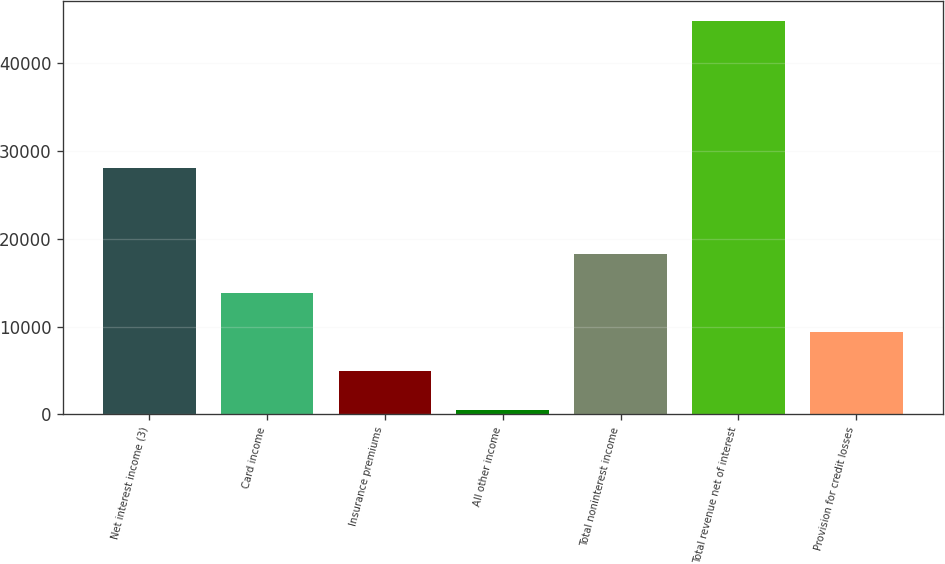Convert chart to OTSL. <chart><loc_0><loc_0><loc_500><loc_500><bar_chart><fcel>Net interest income (3)<fcel>Card income<fcel>Insurance premiums<fcel>All other income<fcel>Total noninterest income<fcel>Total revenue net of interest<fcel>Provision for credit losses<nl><fcel>28059<fcel>13812.4<fcel>4950.8<fcel>520<fcel>18243.2<fcel>44828<fcel>9381.6<nl></chart> 